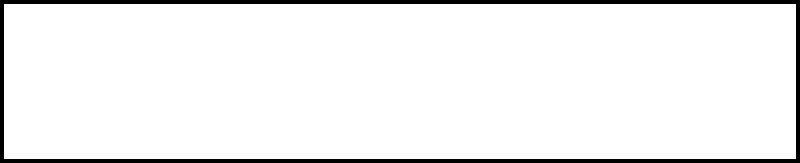A reinforced concrete beam has a rectangular cross-section of 200 mm width and 400 mm depth. The neutral axis is located 160 mm from the top of the beam. Assuming a linear stress distribution, calculate the maximum compressive stress in the concrete if the maximum tensile stress in the reinforcement is 250 MPa. The modular ratio (n) between steel and concrete is 15. To solve this problem, we'll follow these steps:

1) First, let's identify the key information:
   - Beam width (b) = 200 mm
   - Beam depth (d) = 400 mm
   - Neutral axis depth (kd) = 160 mm
   - Maximum tensile stress in steel (f_s) = 250 MPa
   - Modular ratio (n) = 15

2) The stress distribution is assumed to be linear, so we can use similar triangles to set up our equation.

3) Let the maximum compressive stress in concrete be f_c. The depth of the compression zone is kd = 160 mm, and the depth of the tension zone is d - kd = 400 - 160 = 240 mm.

4) Using the principle of similar triangles:

   $$\frac{f_c}{kd} = \frac{f_s}{n(d-kd)}$$

5) Substitute the known values:

   $$\frac{f_c}{160} = \frac{250}{15(400-160)}$$

6) Simplify:

   $$\frac{f_c}{160} = \frac{250}{15(240)} = \frac{250}{3600}$$

7) Cross multiply:

   $$3600f_c = 250 \times 160$$

8) Solve for f_c:

   $$f_c = \frac{250 \times 160}{3600} = 11.11 \text{ MPa}$$

Therefore, the maximum compressive stress in the concrete is approximately 11.11 MPa.
Answer: 11.11 MPa 